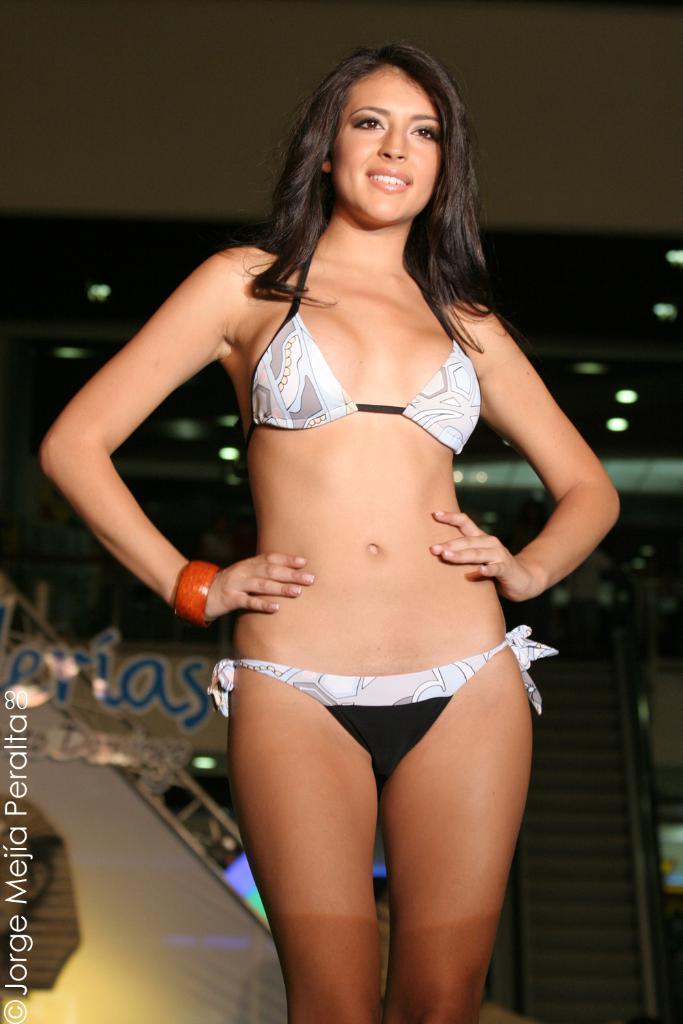How would you summarize this image in a sentence or two? In the picture I can see a woman standing here and smiling. The background of the image is slightly blurred, where I can see ceiling lights and a board. Here I can see the watermark on the left side corner of the image. 